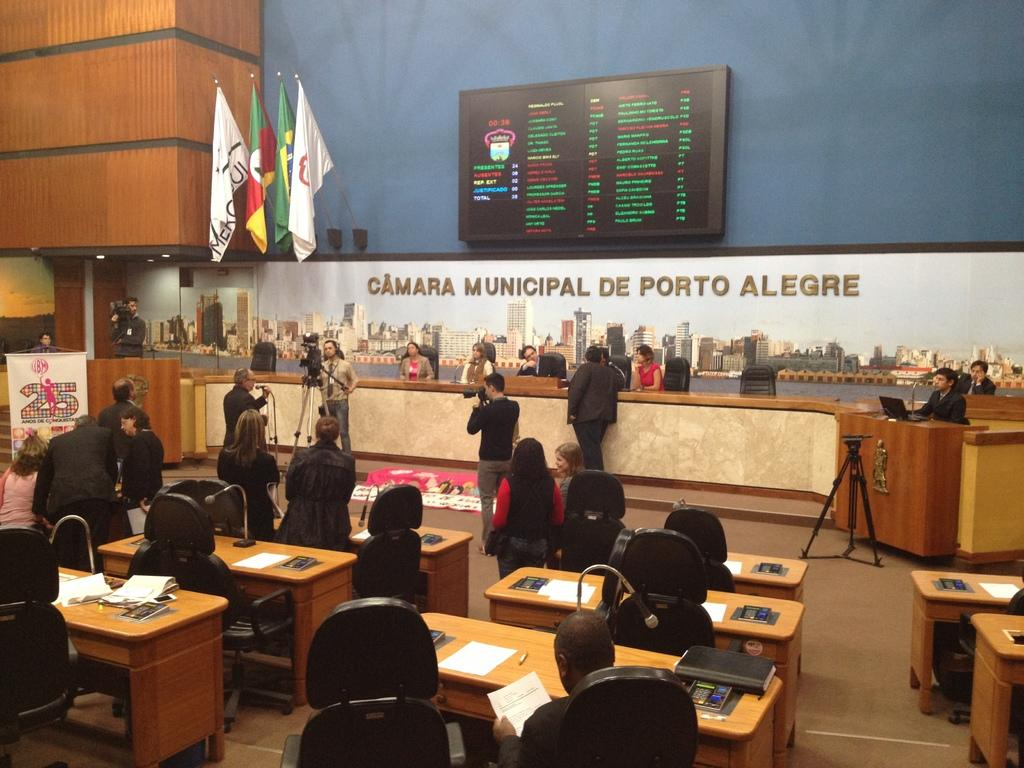What type of structure can be seen in the image? There is a wall in the image. What is hanging on the wall? There is a banner in the image. What are the flags associated with? There are flags in the image. What are the people in the image doing? There are people sitting and standing in the image. What type of furniture is present in the image? There are chairs and tables in the image. What items can be seen on the tables? Papers, books, and microphones (mics) are present on the tables. What arithmetic problem is being solved on the table in the image? There is no arithmetic problem visible in the image. How many passengers are sitting in the chairs in the image? There is no reference to passengers in the image; it features people sitting in chairs. What type of drug is being discussed by the people in the image? There is no mention of drugs or discussions about drugs in the image. 